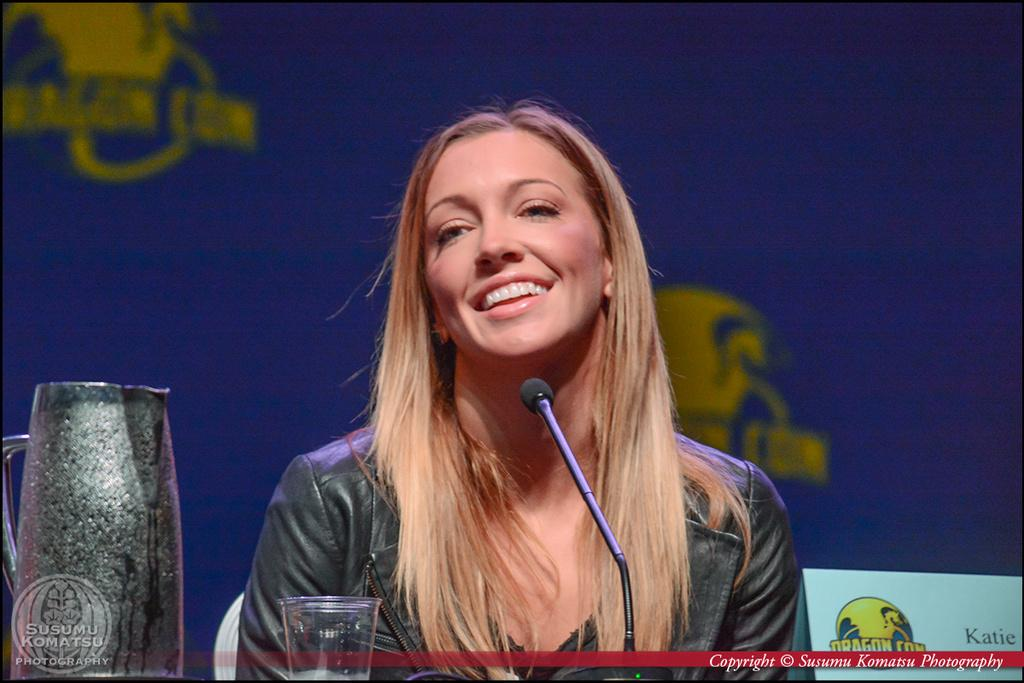Who is the main subject in the image? There is a woman in the image. What is the woman doing in the image? The woman is sitting on a chair. What objects can be seen in the bottom left hand corner of the image? There is a jug and a glass in the bottom left hand corner of the image. What type of polish is the woman applying to her nails in the image? There is no indication in the image that the woman is applying polish to her nails, and therefore no such activity can be observed. 